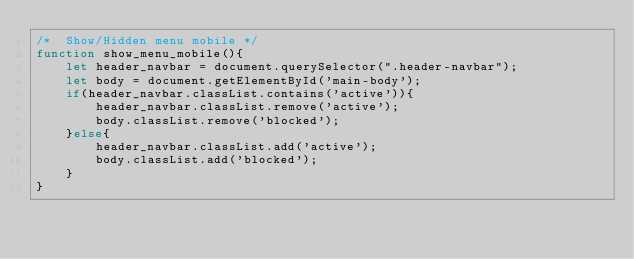Convert code to text. <code><loc_0><loc_0><loc_500><loc_500><_JavaScript_>/*  Show/Hidden menu mobile */
function show_menu_mobile(){
	let header_navbar = document.querySelector(".header-navbar");
	let body = document.getElementById('main-body');
	if(header_navbar.classList.contains('active')){
		header_navbar.classList.remove('active');
		body.classList.remove('blocked');
	}else{
		header_navbar.classList.add('active');
		body.classList.add('blocked');
	}
}</code> 